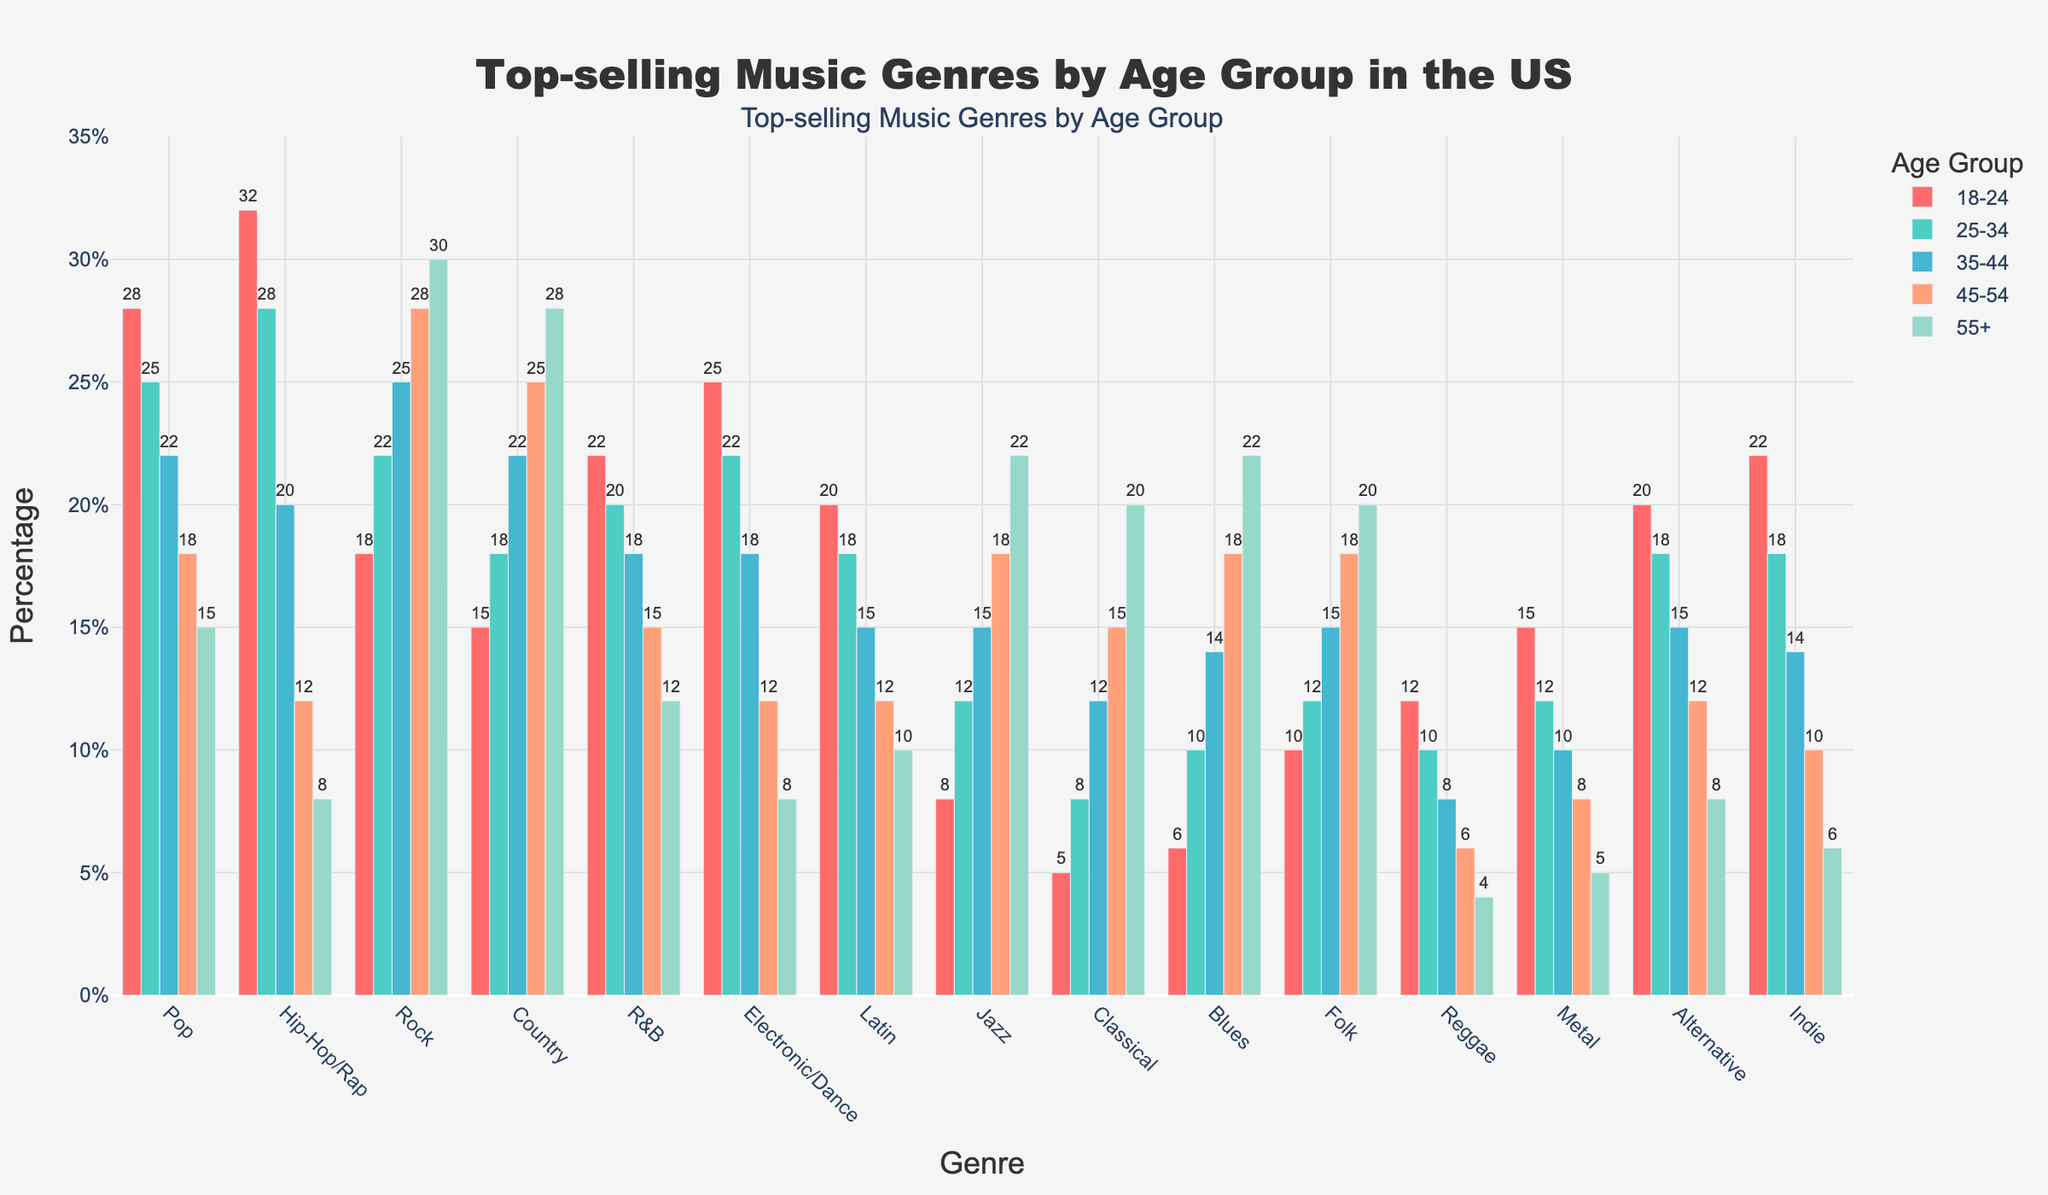Which genre is the most popular among the 18-24 age group? The height of the bars for each genre in the 18-24 age group shows that Hip-Hop/Rap has the highest percentage.
Answer: Hip-Hop/Rap Which age group has the highest preference for Classical music? By comparing the bar heights for Classical music across all age groups, the 55+ age group has the highest bar.
Answer: 55+ What is the difference in preference for Hip-Hop/Rap between the 18-24 and 55+ age groups? The preference for Hip-Hop/Rap in the 18-24 age group is 32% and 8% in the 55+ age group. The difference is 32% - 8% = 24%.
Answer: 24% Which age group has the most balanced preference for Pop, Rock, and Country? By visually comparing the bar heights for Pop, Rock, and Country in each age group, the 35-44 age group has relatively similar heights for these three genres.
Answer: 35-44 Are there any genres where the 45-54 age group has higher preferences compared to the 18-24 age group? By comparing bar heights, Rock, Country, Jazz, Classical, and Blues have higher percentages in the 45-54 age group than in the 18-24 age group.
Answer: Yes What is the average preference percentage for the Electronic/Dance genre across all age groups? Sum the percentages for Electronic/Dance in all age groups (25+22+18+12+8=85), then divide by the number of age groups (5). The average is 85/5=17%.
Answer: 17% Which genre shows a consistent increase in preference as the age group increases? Rock and Jazz show an increasing trend in preference across ascending age groups by comparing the bar heights.
Answer: Rock and Jazz What is the total preference percentage for Indie and Alternative in the 25-34 age group? Add the percentages for Indie and Alternative in the 25-34 age group: 18% (Indie) + 18% (Alternative) = 36%.
Answer: 36% Which genre has the lowest preference among the 25-34 age group? By comparing bar heights, Classical has the lowest preference in the 25-34 age group.
Answer: Classical 